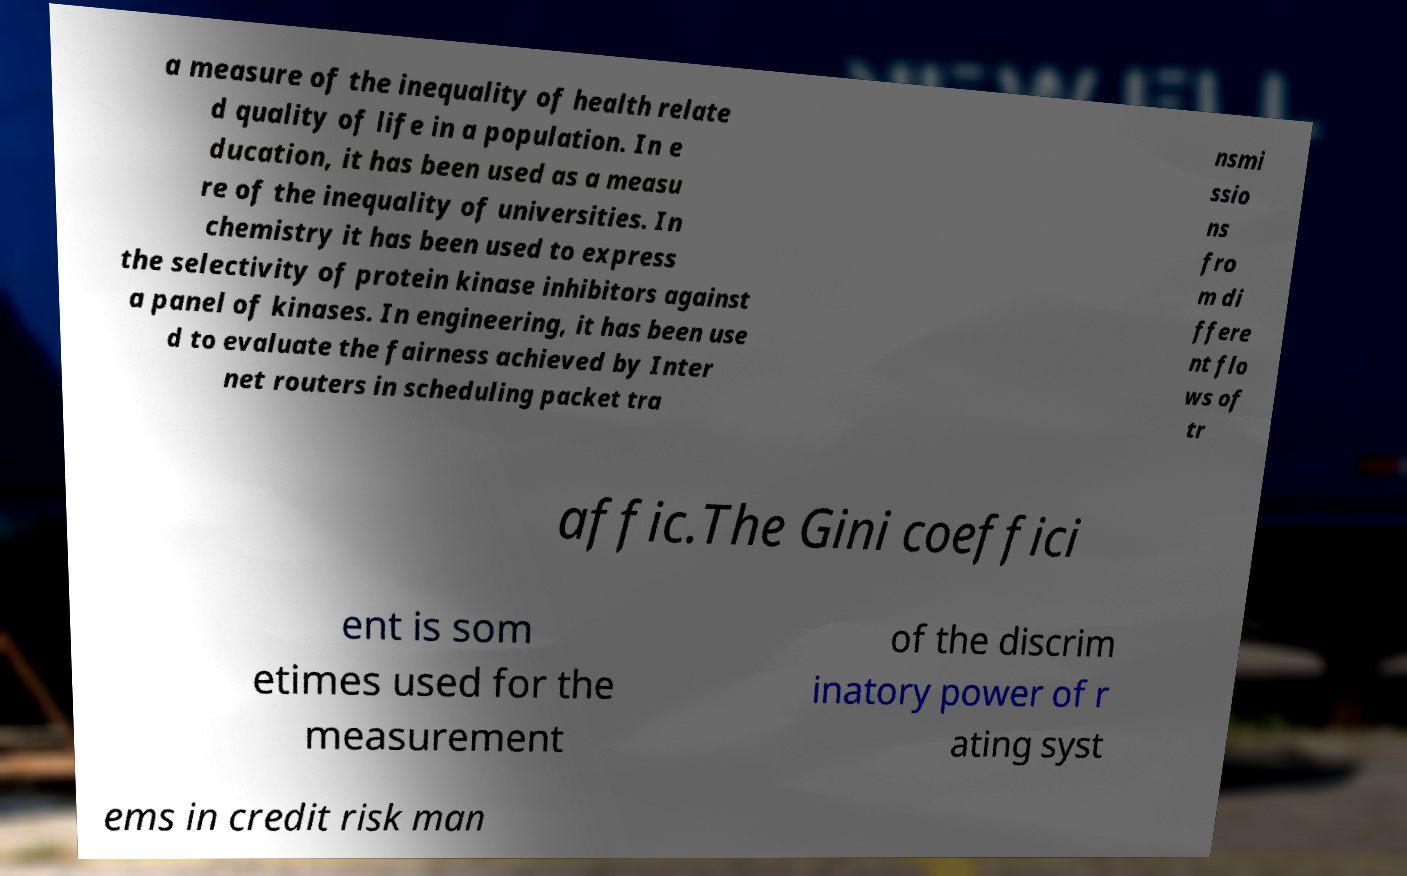What messages or text are displayed in this image? I need them in a readable, typed format. a measure of the inequality of health relate d quality of life in a population. In e ducation, it has been used as a measu re of the inequality of universities. In chemistry it has been used to express the selectivity of protein kinase inhibitors against a panel of kinases. In engineering, it has been use d to evaluate the fairness achieved by Inter net routers in scheduling packet tra nsmi ssio ns fro m di ffere nt flo ws of tr affic.The Gini coeffici ent is som etimes used for the measurement of the discrim inatory power of r ating syst ems in credit risk man 